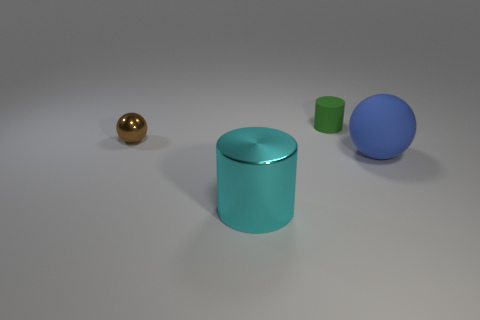There is a big object that is made of the same material as the tiny cylinder; what shape is it?
Your answer should be very brief. Sphere. Does the ball to the right of the brown thing have the same size as the green thing?
Give a very brief answer. No. There is a cylinder that is in front of the rubber thing that is behind the metallic ball; is there a tiny matte object that is in front of it?
Make the answer very short. No. The object that is left of the big ball and in front of the small brown shiny thing has what shape?
Your response must be concise. Cylinder. What color is the thing that is to the right of the matte thing left of the blue matte object?
Offer a terse response. Blue. There is a sphere to the right of the thing that is left of the metal thing in front of the blue sphere; what is its size?
Make the answer very short. Large. Is the material of the tiny brown thing the same as the big thing left of the tiny green cylinder?
Give a very brief answer. Yes. What is the size of the blue ball that is made of the same material as the tiny green cylinder?
Your response must be concise. Large. Is there a large blue thing that has the same shape as the tiny brown metal object?
Provide a short and direct response. Yes. How many things are either large objects on the left side of the big sphere or big blue matte spheres?
Provide a short and direct response. 2. 